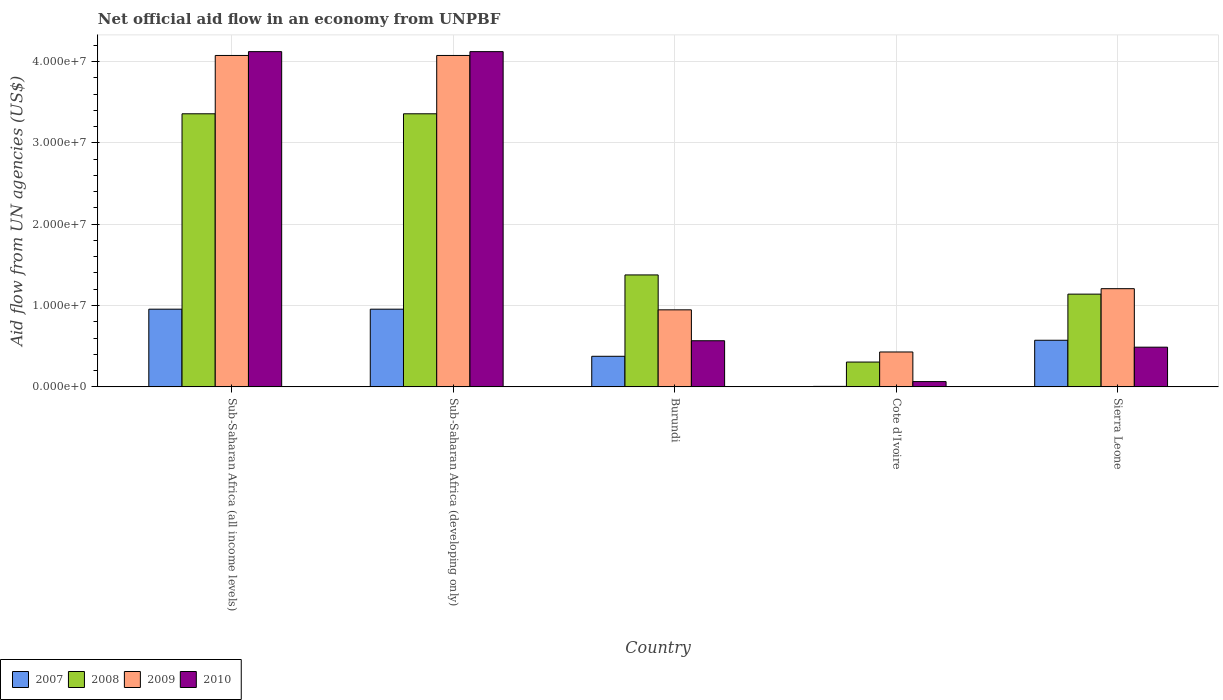How many different coloured bars are there?
Your answer should be compact. 4. How many groups of bars are there?
Provide a succinct answer. 5. Are the number of bars per tick equal to the number of legend labels?
Ensure brevity in your answer.  Yes. Are the number of bars on each tick of the X-axis equal?
Make the answer very short. Yes. How many bars are there on the 1st tick from the left?
Keep it short and to the point. 4. How many bars are there on the 3rd tick from the right?
Your answer should be compact. 4. What is the label of the 3rd group of bars from the left?
Your answer should be compact. Burundi. In how many cases, is the number of bars for a given country not equal to the number of legend labels?
Your answer should be compact. 0. What is the net official aid flow in 2009 in Sub-Saharan Africa (developing only)?
Your answer should be very brief. 4.07e+07. Across all countries, what is the maximum net official aid flow in 2008?
Your answer should be very brief. 3.36e+07. Across all countries, what is the minimum net official aid flow in 2010?
Provide a short and direct response. 6.50e+05. In which country was the net official aid flow in 2008 maximum?
Your answer should be compact. Sub-Saharan Africa (all income levels). In which country was the net official aid flow in 2008 minimum?
Offer a very short reply. Cote d'Ivoire. What is the total net official aid flow in 2010 in the graph?
Give a very brief answer. 9.36e+07. What is the difference between the net official aid flow in 2008 in Burundi and that in Sub-Saharan Africa (all income levels)?
Your answer should be very brief. -1.98e+07. What is the difference between the net official aid flow in 2007 in Sub-Saharan Africa (developing only) and the net official aid flow in 2010 in Cote d'Ivoire?
Your answer should be compact. 8.90e+06. What is the average net official aid flow in 2009 per country?
Provide a short and direct response. 2.15e+07. What is the difference between the net official aid flow of/in 2008 and net official aid flow of/in 2009 in Burundi?
Your response must be concise. 4.29e+06. What is the ratio of the net official aid flow in 2007 in Cote d'Ivoire to that in Sub-Saharan Africa (all income levels)?
Your answer should be compact. 0.01. What is the difference between the highest and the second highest net official aid flow in 2010?
Offer a terse response. 3.55e+07. What is the difference between the highest and the lowest net official aid flow in 2008?
Your answer should be compact. 3.05e+07. Is it the case that in every country, the sum of the net official aid flow in 2010 and net official aid flow in 2007 is greater than the sum of net official aid flow in 2009 and net official aid flow in 2008?
Give a very brief answer. No. What does the 4th bar from the left in Burundi represents?
Make the answer very short. 2010. How many bars are there?
Provide a short and direct response. 20. Are all the bars in the graph horizontal?
Give a very brief answer. No. What is the title of the graph?
Your response must be concise. Net official aid flow in an economy from UNPBF. Does "1978" appear as one of the legend labels in the graph?
Offer a very short reply. No. What is the label or title of the X-axis?
Provide a short and direct response. Country. What is the label or title of the Y-axis?
Provide a succinct answer. Aid flow from UN agencies (US$). What is the Aid flow from UN agencies (US$) in 2007 in Sub-Saharan Africa (all income levels)?
Make the answer very short. 9.55e+06. What is the Aid flow from UN agencies (US$) of 2008 in Sub-Saharan Africa (all income levels)?
Provide a short and direct response. 3.36e+07. What is the Aid flow from UN agencies (US$) in 2009 in Sub-Saharan Africa (all income levels)?
Keep it short and to the point. 4.07e+07. What is the Aid flow from UN agencies (US$) of 2010 in Sub-Saharan Africa (all income levels)?
Offer a very short reply. 4.12e+07. What is the Aid flow from UN agencies (US$) of 2007 in Sub-Saharan Africa (developing only)?
Give a very brief answer. 9.55e+06. What is the Aid flow from UN agencies (US$) of 2008 in Sub-Saharan Africa (developing only)?
Make the answer very short. 3.36e+07. What is the Aid flow from UN agencies (US$) in 2009 in Sub-Saharan Africa (developing only)?
Your answer should be compact. 4.07e+07. What is the Aid flow from UN agencies (US$) of 2010 in Sub-Saharan Africa (developing only)?
Offer a terse response. 4.12e+07. What is the Aid flow from UN agencies (US$) in 2007 in Burundi?
Provide a succinct answer. 3.76e+06. What is the Aid flow from UN agencies (US$) of 2008 in Burundi?
Your answer should be compact. 1.38e+07. What is the Aid flow from UN agencies (US$) in 2009 in Burundi?
Provide a short and direct response. 9.47e+06. What is the Aid flow from UN agencies (US$) of 2010 in Burundi?
Offer a terse response. 5.67e+06. What is the Aid flow from UN agencies (US$) of 2007 in Cote d'Ivoire?
Keep it short and to the point. 6.00e+04. What is the Aid flow from UN agencies (US$) of 2008 in Cote d'Ivoire?
Your response must be concise. 3.05e+06. What is the Aid flow from UN agencies (US$) in 2009 in Cote d'Ivoire?
Keep it short and to the point. 4.29e+06. What is the Aid flow from UN agencies (US$) of 2010 in Cote d'Ivoire?
Give a very brief answer. 6.50e+05. What is the Aid flow from UN agencies (US$) of 2007 in Sierra Leone?
Give a very brief answer. 5.73e+06. What is the Aid flow from UN agencies (US$) in 2008 in Sierra Leone?
Provide a succinct answer. 1.14e+07. What is the Aid flow from UN agencies (US$) of 2009 in Sierra Leone?
Give a very brief answer. 1.21e+07. What is the Aid flow from UN agencies (US$) of 2010 in Sierra Leone?
Offer a terse response. 4.88e+06. Across all countries, what is the maximum Aid flow from UN agencies (US$) of 2007?
Ensure brevity in your answer.  9.55e+06. Across all countries, what is the maximum Aid flow from UN agencies (US$) of 2008?
Your answer should be compact. 3.36e+07. Across all countries, what is the maximum Aid flow from UN agencies (US$) of 2009?
Offer a terse response. 4.07e+07. Across all countries, what is the maximum Aid flow from UN agencies (US$) in 2010?
Give a very brief answer. 4.12e+07. Across all countries, what is the minimum Aid flow from UN agencies (US$) of 2008?
Make the answer very short. 3.05e+06. Across all countries, what is the minimum Aid flow from UN agencies (US$) of 2009?
Give a very brief answer. 4.29e+06. Across all countries, what is the minimum Aid flow from UN agencies (US$) in 2010?
Offer a very short reply. 6.50e+05. What is the total Aid flow from UN agencies (US$) of 2007 in the graph?
Your answer should be compact. 2.86e+07. What is the total Aid flow from UN agencies (US$) of 2008 in the graph?
Keep it short and to the point. 9.54e+07. What is the total Aid flow from UN agencies (US$) in 2009 in the graph?
Ensure brevity in your answer.  1.07e+08. What is the total Aid flow from UN agencies (US$) of 2010 in the graph?
Provide a succinct answer. 9.36e+07. What is the difference between the Aid flow from UN agencies (US$) of 2008 in Sub-Saharan Africa (all income levels) and that in Sub-Saharan Africa (developing only)?
Ensure brevity in your answer.  0. What is the difference between the Aid flow from UN agencies (US$) in 2009 in Sub-Saharan Africa (all income levels) and that in Sub-Saharan Africa (developing only)?
Offer a very short reply. 0. What is the difference between the Aid flow from UN agencies (US$) in 2007 in Sub-Saharan Africa (all income levels) and that in Burundi?
Your answer should be very brief. 5.79e+06. What is the difference between the Aid flow from UN agencies (US$) in 2008 in Sub-Saharan Africa (all income levels) and that in Burundi?
Ensure brevity in your answer.  1.98e+07. What is the difference between the Aid flow from UN agencies (US$) of 2009 in Sub-Saharan Africa (all income levels) and that in Burundi?
Ensure brevity in your answer.  3.13e+07. What is the difference between the Aid flow from UN agencies (US$) in 2010 in Sub-Saharan Africa (all income levels) and that in Burundi?
Your answer should be very brief. 3.55e+07. What is the difference between the Aid flow from UN agencies (US$) of 2007 in Sub-Saharan Africa (all income levels) and that in Cote d'Ivoire?
Provide a short and direct response. 9.49e+06. What is the difference between the Aid flow from UN agencies (US$) in 2008 in Sub-Saharan Africa (all income levels) and that in Cote d'Ivoire?
Your response must be concise. 3.05e+07. What is the difference between the Aid flow from UN agencies (US$) of 2009 in Sub-Saharan Africa (all income levels) and that in Cote d'Ivoire?
Your answer should be compact. 3.64e+07. What is the difference between the Aid flow from UN agencies (US$) of 2010 in Sub-Saharan Africa (all income levels) and that in Cote d'Ivoire?
Offer a very short reply. 4.06e+07. What is the difference between the Aid flow from UN agencies (US$) in 2007 in Sub-Saharan Africa (all income levels) and that in Sierra Leone?
Your answer should be very brief. 3.82e+06. What is the difference between the Aid flow from UN agencies (US$) of 2008 in Sub-Saharan Africa (all income levels) and that in Sierra Leone?
Your answer should be compact. 2.22e+07. What is the difference between the Aid flow from UN agencies (US$) of 2009 in Sub-Saharan Africa (all income levels) and that in Sierra Leone?
Give a very brief answer. 2.87e+07. What is the difference between the Aid flow from UN agencies (US$) in 2010 in Sub-Saharan Africa (all income levels) and that in Sierra Leone?
Offer a very short reply. 3.63e+07. What is the difference between the Aid flow from UN agencies (US$) of 2007 in Sub-Saharan Africa (developing only) and that in Burundi?
Offer a very short reply. 5.79e+06. What is the difference between the Aid flow from UN agencies (US$) in 2008 in Sub-Saharan Africa (developing only) and that in Burundi?
Keep it short and to the point. 1.98e+07. What is the difference between the Aid flow from UN agencies (US$) in 2009 in Sub-Saharan Africa (developing only) and that in Burundi?
Ensure brevity in your answer.  3.13e+07. What is the difference between the Aid flow from UN agencies (US$) of 2010 in Sub-Saharan Africa (developing only) and that in Burundi?
Provide a succinct answer. 3.55e+07. What is the difference between the Aid flow from UN agencies (US$) in 2007 in Sub-Saharan Africa (developing only) and that in Cote d'Ivoire?
Make the answer very short. 9.49e+06. What is the difference between the Aid flow from UN agencies (US$) of 2008 in Sub-Saharan Africa (developing only) and that in Cote d'Ivoire?
Your response must be concise. 3.05e+07. What is the difference between the Aid flow from UN agencies (US$) in 2009 in Sub-Saharan Africa (developing only) and that in Cote d'Ivoire?
Provide a succinct answer. 3.64e+07. What is the difference between the Aid flow from UN agencies (US$) of 2010 in Sub-Saharan Africa (developing only) and that in Cote d'Ivoire?
Offer a terse response. 4.06e+07. What is the difference between the Aid flow from UN agencies (US$) in 2007 in Sub-Saharan Africa (developing only) and that in Sierra Leone?
Your answer should be compact. 3.82e+06. What is the difference between the Aid flow from UN agencies (US$) of 2008 in Sub-Saharan Africa (developing only) and that in Sierra Leone?
Your answer should be compact. 2.22e+07. What is the difference between the Aid flow from UN agencies (US$) in 2009 in Sub-Saharan Africa (developing only) and that in Sierra Leone?
Ensure brevity in your answer.  2.87e+07. What is the difference between the Aid flow from UN agencies (US$) of 2010 in Sub-Saharan Africa (developing only) and that in Sierra Leone?
Make the answer very short. 3.63e+07. What is the difference between the Aid flow from UN agencies (US$) of 2007 in Burundi and that in Cote d'Ivoire?
Make the answer very short. 3.70e+06. What is the difference between the Aid flow from UN agencies (US$) in 2008 in Burundi and that in Cote d'Ivoire?
Provide a short and direct response. 1.07e+07. What is the difference between the Aid flow from UN agencies (US$) of 2009 in Burundi and that in Cote d'Ivoire?
Provide a succinct answer. 5.18e+06. What is the difference between the Aid flow from UN agencies (US$) of 2010 in Burundi and that in Cote d'Ivoire?
Make the answer very short. 5.02e+06. What is the difference between the Aid flow from UN agencies (US$) in 2007 in Burundi and that in Sierra Leone?
Make the answer very short. -1.97e+06. What is the difference between the Aid flow from UN agencies (US$) of 2008 in Burundi and that in Sierra Leone?
Offer a terse response. 2.36e+06. What is the difference between the Aid flow from UN agencies (US$) in 2009 in Burundi and that in Sierra Leone?
Offer a very short reply. -2.60e+06. What is the difference between the Aid flow from UN agencies (US$) in 2010 in Burundi and that in Sierra Leone?
Make the answer very short. 7.90e+05. What is the difference between the Aid flow from UN agencies (US$) in 2007 in Cote d'Ivoire and that in Sierra Leone?
Ensure brevity in your answer.  -5.67e+06. What is the difference between the Aid flow from UN agencies (US$) of 2008 in Cote d'Ivoire and that in Sierra Leone?
Make the answer very short. -8.35e+06. What is the difference between the Aid flow from UN agencies (US$) in 2009 in Cote d'Ivoire and that in Sierra Leone?
Offer a terse response. -7.78e+06. What is the difference between the Aid flow from UN agencies (US$) of 2010 in Cote d'Ivoire and that in Sierra Leone?
Ensure brevity in your answer.  -4.23e+06. What is the difference between the Aid flow from UN agencies (US$) of 2007 in Sub-Saharan Africa (all income levels) and the Aid flow from UN agencies (US$) of 2008 in Sub-Saharan Africa (developing only)?
Make the answer very short. -2.40e+07. What is the difference between the Aid flow from UN agencies (US$) of 2007 in Sub-Saharan Africa (all income levels) and the Aid flow from UN agencies (US$) of 2009 in Sub-Saharan Africa (developing only)?
Make the answer very short. -3.12e+07. What is the difference between the Aid flow from UN agencies (US$) of 2007 in Sub-Saharan Africa (all income levels) and the Aid flow from UN agencies (US$) of 2010 in Sub-Saharan Africa (developing only)?
Your answer should be compact. -3.17e+07. What is the difference between the Aid flow from UN agencies (US$) in 2008 in Sub-Saharan Africa (all income levels) and the Aid flow from UN agencies (US$) in 2009 in Sub-Saharan Africa (developing only)?
Your answer should be very brief. -7.17e+06. What is the difference between the Aid flow from UN agencies (US$) in 2008 in Sub-Saharan Africa (all income levels) and the Aid flow from UN agencies (US$) in 2010 in Sub-Saharan Africa (developing only)?
Offer a very short reply. -7.64e+06. What is the difference between the Aid flow from UN agencies (US$) of 2009 in Sub-Saharan Africa (all income levels) and the Aid flow from UN agencies (US$) of 2010 in Sub-Saharan Africa (developing only)?
Provide a short and direct response. -4.70e+05. What is the difference between the Aid flow from UN agencies (US$) in 2007 in Sub-Saharan Africa (all income levels) and the Aid flow from UN agencies (US$) in 2008 in Burundi?
Provide a succinct answer. -4.21e+06. What is the difference between the Aid flow from UN agencies (US$) of 2007 in Sub-Saharan Africa (all income levels) and the Aid flow from UN agencies (US$) of 2009 in Burundi?
Keep it short and to the point. 8.00e+04. What is the difference between the Aid flow from UN agencies (US$) in 2007 in Sub-Saharan Africa (all income levels) and the Aid flow from UN agencies (US$) in 2010 in Burundi?
Offer a very short reply. 3.88e+06. What is the difference between the Aid flow from UN agencies (US$) in 2008 in Sub-Saharan Africa (all income levels) and the Aid flow from UN agencies (US$) in 2009 in Burundi?
Offer a very short reply. 2.41e+07. What is the difference between the Aid flow from UN agencies (US$) in 2008 in Sub-Saharan Africa (all income levels) and the Aid flow from UN agencies (US$) in 2010 in Burundi?
Offer a terse response. 2.79e+07. What is the difference between the Aid flow from UN agencies (US$) of 2009 in Sub-Saharan Africa (all income levels) and the Aid flow from UN agencies (US$) of 2010 in Burundi?
Give a very brief answer. 3.51e+07. What is the difference between the Aid flow from UN agencies (US$) of 2007 in Sub-Saharan Africa (all income levels) and the Aid flow from UN agencies (US$) of 2008 in Cote d'Ivoire?
Give a very brief answer. 6.50e+06. What is the difference between the Aid flow from UN agencies (US$) of 2007 in Sub-Saharan Africa (all income levels) and the Aid flow from UN agencies (US$) of 2009 in Cote d'Ivoire?
Provide a succinct answer. 5.26e+06. What is the difference between the Aid flow from UN agencies (US$) in 2007 in Sub-Saharan Africa (all income levels) and the Aid flow from UN agencies (US$) in 2010 in Cote d'Ivoire?
Keep it short and to the point. 8.90e+06. What is the difference between the Aid flow from UN agencies (US$) in 2008 in Sub-Saharan Africa (all income levels) and the Aid flow from UN agencies (US$) in 2009 in Cote d'Ivoire?
Ensure brevity in your answer.  2.93e+07. What is the difference between the Aid flow from UN agencies (US$) in 2008 in Sub-Saharan Africa (all income levels) and the Aid flow from UN agencies (US$) in 2010 in Cote d'Ivoire?
Offer a terse response. 3.29e+07. What is the difference between the Aid flow from UN agencies (US$) of 2009 in Sub-Saharan Africa (all income levels) and the Aid flow from UN agencies (US$) of 2010 in Cote d'Ivoire?
Keep it short and to the point. 4.01e+07. What is the difference between the Aid flow from UN agencies (US$) of 2007 in Sub-Saharan Africa (all income levels) and the Aid flow from UN agencies (US$) of 2008 in Sierra Leone?
Your answer should be compact. -1.85e+06. What is the difference between the Aid flow from UN agencies (US$) in 2007 in Sub-Saharan Africa (all income levels) and the Aid flow from UN agencies (US$) in 2009 in Sierra Leone?
Provide a succinct answer. -2.52e+06. What is the difference between the Aid flow from UN agencies (US$) in 2007 in Sub-Saharan Africa (all income levels) and the Aid flow from UN agencies (US$) in 2010 in Sierra Leone?
Give a very brief answer. 4.67e+06. What is the difference between the Aid flow from UN agencies (US$) in 2008 in Sub-Saharan Africa (all income levels) and the Aid flow from UN agencies (US$) in 2009 in Sierra Leone?
Provide a succinct answer. 2.15e+07. What is the difference between the Aid flow from UN agencies (US$) in 2008 in Sub-Saharan Africa (all income levels) and the Aid flow from UN agencies (US$) in 2010 in Sierra Leone?
Your response must be concise. 2.87e+07. What is the difference between the Aid flow from UN agencies (US$) in 2009 in Sub-Saharan Africa (all income levels) and the Aid flow from UN agencies (US$) in 2010 in Sierra Leone?
Offer a very short reply. 3.59e+07. What is the difference between the Aid flow from UN agencies (US$) in 2007 in Sub-Saharan Africa (developing only) and the Aid flow from UN agencies (US$) in 2008 in Burundi?
Offer a very short reply. -4.21e+06. What is the difference between the Aid flow from UN agencies (US$) in 2007 in Sub-Saharan Africa (developing only) and the Aid flow from UN agencies (US$) in 2009 in Burundi?
Provide a succinct answer. 8.00e+04. What is the difference between the Aid flow from UN agencies (US$) in 2007 in Sub-Saharan Africa (developing only) and the Aid flow from UN agencies (US$) in 2010 in Burundi?
Provide a succinct answer. 3.88e+06. What is the difference between the Aid flow from UN agencies (US$) in 2008 in Sub-Saharan Africa (developing only) and the Aid flow from UN agencies (US$) in 2009 in Burundi?
Your answer should be compact. 2.41e+07. What is the difference between the Aid flow from UN agencies (US$) of 2008 in Sub-Saharan Africa (developing only) and the Aid flow from UN agencies (US$) of 2010 in Burundi?
Ensure brevity in your answer.  2.79e+07. What is the difference between the Aid flow from UN agencies (US$) in 2009 in Sub-Saharan Africa (developing only) and the Aid flow from UN agencies (US$) in 2010 in Burundi?
Your answer should be very brief. 3.51e+07. What is the difference between the Aid flow from UN agencies (US$) in 2007 in Sub-Saharan Africa (developing only) and the Aid flow from UN agencies (US$) in 2008 in Cote d'Ivoire?
Offer a very short reply. 6.50e+06. What is the difference between the Aid flow from UN agencies (US$) in 2007 in Sub-Saharan Africa (developing only) and the Aid flow from UN agencies (US$) in 2009 in Cote d'Ivoire?
Offer a very short reply. 5.26e+06. What is the difference between the Aid flow from UN agencies (US$) of 2007 in Sub-Saharan Africa (developing only) and the Aid flow from UN agencies (US$) of 2010 in Cote d'Ivoire?
Provide a short and direct response. 8.90e+06. What is the difference between the Aid flow from UN agencies (US$) of 2008 in Sub-Saharan Africa (developing only) and the Aid flow from UN agencies (US$) of 2009 in Cote d'Ivoire?
Provide a succinct answer. 2.93e+07. What is the difference between the Aid flow from UN agencies (US$) in 2008 in Sub-Saharan Africa (developing only) and the Aid flow from UN agencies (US$) in 2010 in Cote d'Ivoire?
Provide a short and direct response. 3.29e+07. What is the difference between the Aid flow from UN agencies (US$) of 2009 in Sub-Saharan Africa (developing only) and the Aid flow from UN agencies (US$) of 2010 in Cote d'Ivoire?
Your answer should be very brief. 4.01e+07. What is the difference between the Aid flow from UN agencies (US$) of 2007 in Sub-Saharan Africa (developing only) and the Aid flow from UN agencies (US$) of 2008 in Sierra Leone?
Keep it short and to the point. -1.85e+06. What is the difference between the Aid flow from UN agencies (US$) in 2007 in Sub-Saharan Africa (developing only) and the Aid flow from UN agencies (US$) in 2009 in Sierra Leone?
Give a very brief answer. -2.52e+06. What is the difference between the Aid flow from UN agencies (US$) in 2007 in Sub-Saharan Africa (developing only) and the Aid flow from UN agencies (US$) in 2010 in Sierra Leone?
Your answer should be compact. 4.67e+06. What is the difference between the Aid flow from UN agencies (US$) of 2008 in Sub-Saharan Africa (developing only) and the Aid flow from UN agencies (US$) of 2009 in Sierra Leone?
Provide a short and direct response. 2.15e+07. What is the difference between the Aid flow from UN agencies (US$) of 2008 in Sub-Saharan Africa (developing only) and the Aid flow from UN agencies (US$) of 2010 in Sierra Leone?
Provide a succinct answer. 2.87e+07. What is the difference between the Aid flow from UN agencies (US$) of 2009 in Sub-Saharan Africa (developing only) and the Aid flow from UN agencies (US$) of 2010 in Sierra Leone?
Make the answer very short. 3.59e+07. What is the difference between the Aid flow from UN agencies (US$) of 2007 in Burundi and the Aid flow from UN agencies (US$) of 2008 in Cote d'Ivoire?
Keep it short and to the point. 7.10e+05. What is the difference between the Aid flow from UN agencies (US$) in 2007 in Burundi and the Aid flow from UN agencies (US$) in 2009 in Cote d'Ivoire?
Ensure brevity in your answer.  -5.30e+05. What is the difference between the Aid flow from UN agencies (US$) of 2007 in Burundi and the Aid flow from UN agencies (US$) of 2010 in Cote d'Ivoire?
Make the answer very short. 3.11e+06. What is the difference between the Aid flow from UN agencies (US$) of 2008 in Burundi and the Aid flow from UN agencies (US$) of 2009 in Cote d'Ivoire?
Your response must be concise. 9.47e+06. What is the difference between the Aid flow from UN agencies (US$) in 2008 in Burundi and the Aid flow from UN agencies (US$) in 2010 in Cote d'Ivoire?
Provide a short and direct response. 1.31e+07. What is the difference between the Aid flow from UN agencies (US$) of 2009 in Burundi and the Aid flow from UN agencies (US$) of 2010 in Cote d'Ivoire?
Offer a terse response. 8.82e+06. What is the difference between the Aid flow from UN agencies (US$) in 2007 in Burundi and the Aid flow from UN agencies (US$) in 2008 in Sierra Leone?
Ensure brevity in your answer.  -7.64e+06. What is the difference between the Aid flow from UN agencies (US$) in 2007 in Burundi and the Aid flow from UN agencies (US$) in 2009 in Sierra Leone?
Provide a short and direct response. -8.31e+06. What is the difference between the Aid flow from UN agencies (US$) in 2007 in Burundi and the Aid flow from UN agencies (US$) in 2010 in Sierra Leone?
Offer a very short reply. -1.12e+06. What is the difference between the Aid flow from UN agencies (US$) in 2008 in Burundi and the Aid flow from UN agencies (US$) in 2009 in Sierra Leone?
Your answer should be very brief. 1.69e+06. What is the difference between the Aid flow from UN agencies (US$) of 2008 in Burundi and the Aid flow from UN agencies (US$) of 2010 in Sierra Leone?
Ensure brevity in your answer.  8.88e+06. What is the difference between the Aid flow from UN agencies (US$) in 2009 in Burundi and the Aid flow from UN agencies (US$) in 2010 in Sierra Leone?
Your answer should be compact. 4.59e+06. What is the difference between the Aid flow from UN agencies (US$) of 2007 in Cote d'Ivoire and the Aid flow from UN agencies (US$) of 2008 in Sierra Leone?
Give a very brief answer. -1.13e+07. What is the difference between the Aid flow from UN agencies (US$) in 2007 in Cote d'Ivoire and the Aid flow from UN agencies (US$) in 2009 in Sierra Leone?
Make the answer very short. -1.20e+07. What is the difference between the Aid flow from UN agencies (US$) of 2007 in Cote d'Ivoire and the Aid flow from UN agencies (US$) of 2010 in Sierra Leone?
Offer a very short reply. -4.82e+06. What is the difference between the Aid flow from UN agencies (US$) of 2008 in Cote d'Ivoire and the Aid flow from UN agencies (US$) of 2009 in Sierra Leone?
Ensure brevity in your answer.  -9.02e+06. What is the difference between the Aid flow from UN agencies (US$) in 2008 in Cote d'Ivoire and the Aid flow from UN agencies (US$) in 2010 in Sierra Leone?
Your answer should be very brief. -1.83e+06. What is the difference between the Aid flow from UN agencies (US$) of 2009 in Cote d'Ivoire and the Aid flow from UN agencies (US$) of 2010 in Sierra Leone?
Offer a very short reply. -5.90e+05. What is the average Aid flow from UN agencies (US$) of 2007 per country?
Provide a short and direct response. 5.73e+06. What is the average Aid flow from UN agencies (US$) of 2008 per country?
Give a very brief answer. 1.91e+07. What is the average Aid flow from UN agencies (US$) of 2009 per country?
Give a very brief answer. 2.15e+07. What is the average Aid flow from UN agencies (US$) of 2010 per country?
Offer a very short reply. 1.87e+07. What is the difference between the Aid flow from UN agencies (US$) in 2007 and Aid flow from UN agencies (US$) in 2008 in Sub-Saharan Africa (all income levels)?
Your answer should be compact. -2.40e+07. What is the difference between the Aid flow from UN agencies (US$) of 2007 and Aid flow from UN agencies (US$) of 2009 in Sub-Saharan Africa (all income levels)?
Your response must be concise. -3.12e+07. What is the difference between the Aid flow from UN agencies (US$) in 2007 and Aid flow from UN agencies (US$) in 2010 in Sub-Saharan Africa (all income levels)?
Provide a succinct answer. -3.17e+07. What is the difference between the Aid flow from UN agencies (US$) in 2008 and Aid flow from UN agencies (US$) in 2009 in Sub-Saharan Africa (all income levels)?
Provide a succinct answer. -7.17e+06. What is the difference between the Aid flow from UN agencies (US$) in 2008 and Aid flow from UN agencies (US$) in 2010 in Sub-Saharan Africa (all income levels)?
Your answer should be compact. -7.64e+06. What is the difference between the Aid flow from UN agencies (US$) in 2009 and Aid flow from UN agencies (US$) in 2010 in Sub-Saharan Africa (all income levels)?
Make the answer very short. -4.70e+05. What is the difference between the Aid flow from UN agencies (US$) in 2007 and Aid flow from UN agencies (US$) in 2008 in Sub-Saharan Africa (developing only)?
Provide a short and direct response. -2.40e+07. What is the difference between the Aid flow from UN agencies (US$) in 2007 and Aid flow from UN agencies (US$) in 2009 in Sub-Saharan Africa (developing only)?
Ensure brevity in your answer.  -3.12e+07. What is the difference between the Aid flow from UN agencies (US$) in 2007 and Aid flow from UN agencies (US$) in 2010 in Sub-Saharan Africa (developing only)?
Ensure brevity in your answer.  -3.17e+07. What is the difference between the Aid flow from UN agencies (US$) in 2008 and Aid flow from UN agencies (US$) in 2009 in Sub-Saharan Africa (developing only)?
Your response must be concise. -7.17e+06. What is the difference between the Aid flow from UN agencies (US$) in 2008 and Aid flow from UN agencies (US$) in 2010 in Sub-Saharan Africa (developing only)?
Provide a short and direct response. -7.64e+06. What is the difference between the Aid flow from UN agencies (US$) of 2009 and Aid flow from UN agencies (US$) of 2010 in Sub-Saharan Africa (developing only)?
Your response must be concise. -4.70e+05. What is the difference between the Aid flow from UN agencies (US$) in 2007 and Aid flow from UN agencies (US$) in 2008 in Burundi?
Offer a terse response. -1.00e+07. What is the difference between the Aid flow from UN agencies (US$) in 2007 and Aid flow from UN agencies (US$) in 2009 in Burundi?
Give a very brief answer. -5.71e+06. What is the difference between the Aid flow from UN agencies (US$) of 2007 and Aid flow from UN agencies (US$) of 2010 in Burundi?
Offer a terse response. -1.91e+06. What is the difference between the Aid flow from UN agencies (US$) of 2008 and Aid flow from UN agencies (US$) of 2009 in Burundi?
Your answer should be very brief. 4.29e+06. What is the difference between the Aid flow from UN agencies (US$) of 2008 and Aid flow from UN agencies (US$) of 2010 in Burundi?
Your answer should be compact. 8.09e+06. What is the difference between the Aid flow from UN agencies (US$) of 2009 and Aid flow from UN agencies (US$) of 2010 in Burundi?
Your answer should be very brief. 3.80e+06. What is the difference between the Aid flow from UN agencies (US$) in 2007 and Aid flow from UN agencies (US$) in 2008 in Cote d'Ivoire?
Keep it short and to the point. -2.99e+06. What is the difference between the Aid flow from UN agencies (US$) in 2007 and Aid flow from UN agencies (US$) in 2009 in Cote d'Ivoire?
Provide a short and direct response. -4.23e+06. What is the difference between the Aid flow from UN agencies (US$) in 2007 and Aid flow from UN agencies (US$) in 2010 in Cote d'Ivoire?
Your answer should be compact. -5.90e+05. What is the difference between the Aid flow from UN agencies (US$) in 2008 and Aid flow from UN agencies (US$) in 2009 in Cote d'Ivoire?
Keep it short and to the point. -1.24e+06. What is the difference between the Aid flow from UN agencies (US$) in 2008 and Aid flow from UN agencies (US$) in 2010 in Cote d'Ivoire?
Make the answer very short. 2.40e+06. What is the difference between the Aid flow from UN agencies (US$) of 2009 and Aid flow from UN agencies (US$) of 2010 in Cote d'Ivoire?
Your answer should be compact. 3.64e+06. What is the difference between the Aid flow from UN agencies (US$) of 2007 and Aid flow from UN agencies (US$) of 2008 in Sierra Leone?
Offer a terse response. -5.67e+06. What is the difference between the Aid flow from UN agencies (US$) in 2007 and Aid flow from UN agencies (US$) in 2009 in Sierra Leone?
Your answer should be compact. -6.34e+06. What is the difference between the Aid flow from UN agencies (US$) in 2007 and Aid flow from UN agencies (US$) in 2010 in Sierra Leone?
Provide a short and direct response. 8.50e+05. What is the difference between the Aid flow from UN agencies (US$) in 2008 and Aid flow from UN agencies (US$) in 2009 in Sierra Leone?
Offer a very short reply. -6.70e+05. What is the difference between the Aid flow from UN agencies (US$) in 2008 and Aid flow from UN agencies (US$) in 2010 in Sierra Leone?
Offer a very short reply. 6.52e+06. What is the difference between the Aid flow from UN agencies (US$) of 2009 and Aid flow from UN agencies (US$) of 2010 in Sierra Leone?
Provide a short and direct response. 7.19e+06. What is the ratio of the Aid flow from UN agencies (US$) of 2008 in Sub-Saharan Africa (all income levels) to that in Sub-Saharan Africa (developing only)?
Ensure brevity in your answer.  1. What is the ratio of the Aid flow from UN agencies (US$) of 2007 in Sub-Saharan Africa (all income levels) to that in Burundi?
Ensure brevity in your answer.  2.54. What is the ratio of the Aid flow from UN agencies (US$) in 2008 in Sub-Saharan Africa (all income levels) to that in Burundi?
Make the answer very short. 2.44. What is the ratio of the Aid flow from UN agencies (US$) of 2009 in Sub-Saharan Africa (all income levels) to that in Burundi?
Provide a succinct answer. 4.3. What is the ratio of the Aid flow from UN agencies (US$) of 2010 in Sub-Saharan Africa (all income levels) to that in Burundi?
Provide a short and direct response. 7.27. What is the ratio of the Aid flow from UN agencies (US$) of 2007 in Sub-Saharan Africa (all income levels) to that in Cote d'Ivoire?
Keep it short and to the point. 159.17. What is the ratio of the Aid flow from UN agencies (US$) in 2008 in Sub-Saharan Africa (all income levels) to that in Cote d'Ivoire?
Keep it short and to the point. 11.01. What is the ratio of the Aid flow from UN agencies (US$) in 2009 in Sub-Saharan Africa (all income levels) to that in Cote d'Ivoire?
Keep it short and to the point. 9.5. What is the ratio of the Aid flow from UN agencies (US$) in 2010 in Sub-Saharan Africa (all income levels) to that in Cote d'Ivoire?
Offer a very short reply. 63.4. What is the ratio of the Aid flow from UN agencies (US$) of 2008 in Sub-Saharan Africa (all income levels) to that in Sierra Leone?
Ensure brevity in your answer.  2.94. What is the ratio of the Aid flow from UN agencies (US$) of 2009 in Sub-Saharan Africa (all income levels) to that in Sierra Leone?
Make the answer very short. 3.38. What is the ratio of the Aid flow from UN agencies (US$) in 2010 in Sub-Saharan Africa (all income levels) to that in Sierra Leone?
Keep it short and to the point. 8.44. What is the ratio of the Aid flow from UN agencies (US$) in 2007 in Sub-Saharan Africa (developing only) to that in Burundi?
Provide a succinct answer. 2.54. What is the ratio of the Aid flow from UN agencies (US$) of 2008 in Sub-Saharan Africa (developing only) to that in Burundi?
Your answer should be compact. 2.44. What is the ratio of the Aid flow from UN agencies (US$) in 2009 in Sub-Saharan Africa (developing only) to that in Burundi?
Provide a short and direct response. 4.3. What is the ratio of the Aid flow from UN agencies (US$) of 2010 in Sub-Saharan Africa (developing only) to that in Burundi?
Offer a very short reply. 7.27. What is the ratio of the Aid flow from UN agencies (US$) of 2007 in Sub-Saharan Africa (developing only) to that in Cote d'Ivoire?
Your answer should be very brief. 159.17. What is the ratio of the Aid flow from UN agencies (US$) of 2008 in Sub-Saharan Africa (developing only) to that in Cote d'Ivoire?
Offer a terse response. 11.01. What is the ratio of the Aid flow from UN agencies (US$) of 2009 in Sub-Saharan Africa (developing only) to that in Cote d'Ivoire?
Offer a terse response. 9.5. What is the ratio of the Aid flow from UN agencies (US$) in 2010 in Sub-Saharan Africa (developing only) to that in Cote d'Ivoire?
Keep it short and to the point. 63.4. What is the ratio of the Aid flow from UN agencies (US$) of 2008 in Sub-Saharan Africa (developing only) to that in Sierra Leone?
Your answer should be very brief. 2.94. What is the ratio of the Aid flow from UN agencies (US$) in 2009 in Sub-Saharan Africa (developing only) to that in Sierra Leone?
Keep it short and to the point. 3.38. What is the ratio of the Aid flow from UN agencies (US$) of 2010 in Sub-Saharan Africa (developing only) to that in Sierra Leone?
Provide a short and direct response. 8.44. What is the ratio of the Aid flow from UN agencies (US$) of 2007 in Burundi to that in Cote d'Ivoire?
Ensure brevity in your answer.  62.67. What is the ratio of the Aid flow from UN agencies (US$) in 2008 in Burundi to that in Cote d'Ivoire?
Provide a succinct answer. 4.51. What is the ratio of the Aid flow from UN agencies (US$) in 2009 in Burundi to that in Cote d'Ivoire?
Provide a succinct answer. 2.21. What is the ratio of the Aid flow from UN agencies (US$) of 2010 in Burundi to that in Cote d'Ivoire?
Provide a short and direct response. 8.72. What is the ratio of the Aid flow from UN agencies (US$) of 2007 in Burundi to that in Sierra Leone?
Keep it short and to the point. 0.66. What is the ratio of the Aid flow from UN agencies (US$) in 2008 in Burundi to that in Sierra Leone?
Provide a short and direct response. 1.21. What is the ratio of the Aid flow from UN agencies (US$) of 2009 in Burundi to that in Sierra Leone?
Your answer should be very brief. 0.78. What is the ratio of the Aid flow from UN agencies (US$) in 2010 in Burundi to that in Sierra Leone?
Your answer should be very brief. 1.16. What is the ratio of the Aid flow from UN agencies (US$) of 2007 in Cote d'Ivoire to that in Sierra Leone?
Keep it short and to the point. 0.01. What is the ratio of the Aid flow from UN agencies (US$) of 2008 in Cote d'Ivoire to that in Sierra Leone?
Give a very brief answer. 0.27. What is the ratio of the Aid flow from UN agencies (US$) in 2009 in Cote d'Ivoire to that in Sierra Leone?
Your answer should be compact. 0.36. What is the ratio of the Aid flow from UN agencies (US$) in 2010 in Cote d'Ivoire to that in Sierra Leone?
Make the answer very short. 0.13. What is the difference between the highest and the second highest Aid flow from UN agencies (US$) of 2007?
Provide a short and direct response. 0. What is the difference between the highest and the lowest Aid flow from UN agencies (US$) of 2007?
Your answer should be compact. 9.49e+06. What is the difference between the highest and the lowest Aid flow from UN agencies (US$) of 2008?
Offer a terse response. 3.05e+07. What is the difference between the highest and the lowest Aid flow from UN agencies (US$) of 2009?
Provide a succinct answer. 3.64e+07. What is the difference between the highest and the lowest Aid flow from UN agencies (US$) in 2010?
Ensure brevity in your answer.  4.06e+07. 